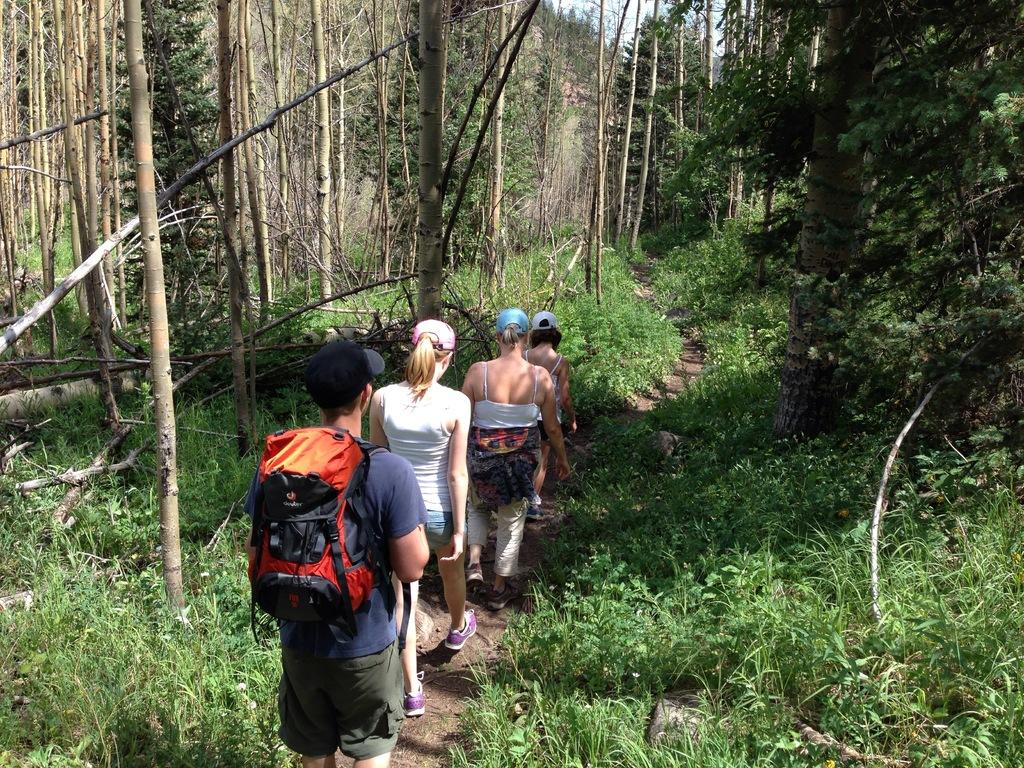How many people are present in the image? There are four people in the image. What are the people doing in the image? The people are walking on a pathway. What type of vegetation can be seen in the image? There are trees and plants in the image. What color is the rose in the image? There is no rose present in the image. What word is written on the pathway in the image? There are no words written on the pathway in the image. 